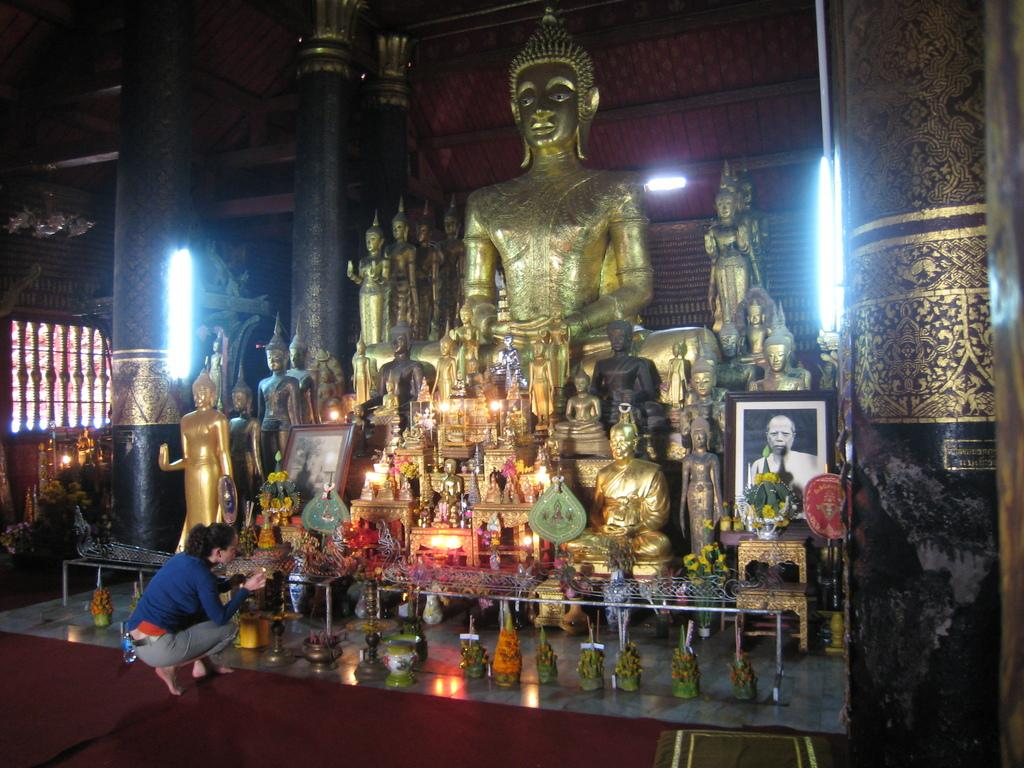What type of objects can be seen in the image? There are statues in the image. Where is the photo frame located in the image? The photo frame is on the right side of the image. What is on the table in the image? There is a flower vase on a table in the image. Can you describe the human in the image? A human is visible in the image. What type of illumination is present in the image? There are lights in the image. What type of fire can be seen in the image? There is no fire present in the image. What is the view like in the image? The view is not mentioned in the provided facts, so it cannot be determined from the image. 